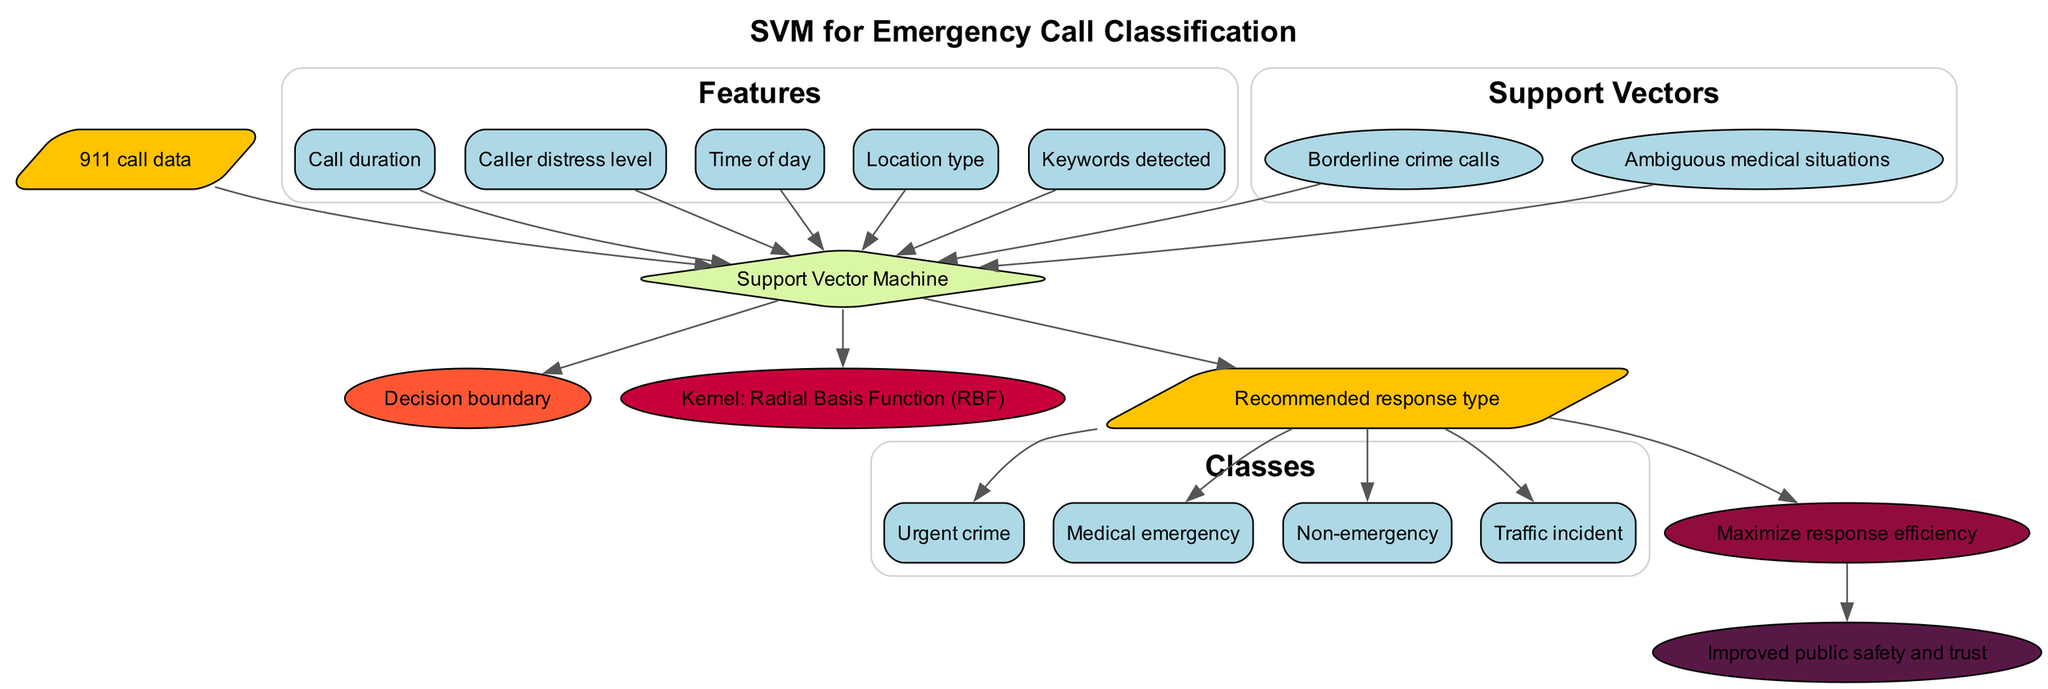What are the features considered in the SVM? The features listed in the diagram include "Call duration", "Caller distress level", "Time of day", "Location type", and "Keywords detected". These are presented in a subgraph labeled "Features".
Answer: Call duration, Caller distress level, Time of day, Location type, Keywords detected How many classes are defined for emergency call classification? The diagram specifies four distinct classes for emergency call classification: "Urgent crime", "Medical emergency", "Non-emergency", and "Traffic incident". This is shown in a subgraph labeled "Classes".
Answer: Four What is the hyperplane referred to in the diagram? The diagram labels the hyperplane as "Decision boundary". It is represented in an ellipse node connected to the Support Vector Machine node.
Answer: Decision boundary What are the support vectors mentioned? The support vectors listed in the diagram are "Borderline crime calls" and "Ambiguous medical situations". These are shown in a subgraph labeled "Support Vectors".
Answer: Borderline crime calls, Ambiguous medical situations What is the kernel function used in this SVM? The kernel function used in the SVM is labeled as "Radial Basis Function (RBF)" in the diagram, and it's depicted in an ellipse node.
Answer: Radial Basis Function (RBF) Which node is connected to the optimization goal? The optimization goal, stated as "Maximize response efficiency," is connected to the output node. It indicates a flow from the output node towards this optimization goal.
Answer: Maximize response efficiency How does the community impact relate to the output? The "Improved public safety and trust" impacts the community positively and is directly connected to the optimization goal. This shows that the ultimate aim of classification is not just efficiency but also enhancing community relations.
Answer: Improved public safety and trust What does the input node represent? The input node represents the data being processed, specifically labeled as "911 call data". This is the starting point for the SVM process in the diagram.
Answer: 911 call data 